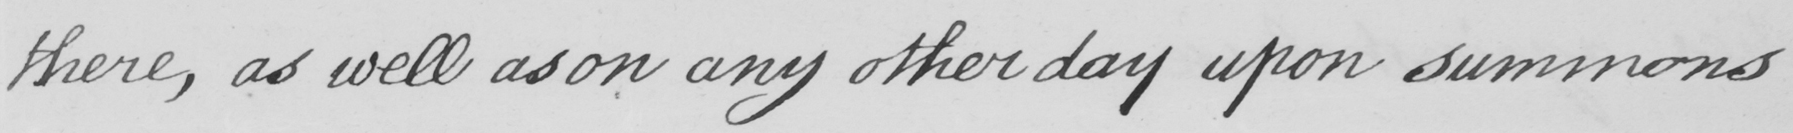What is written in this line of handwriting? there , as well as on any other day upon summons 